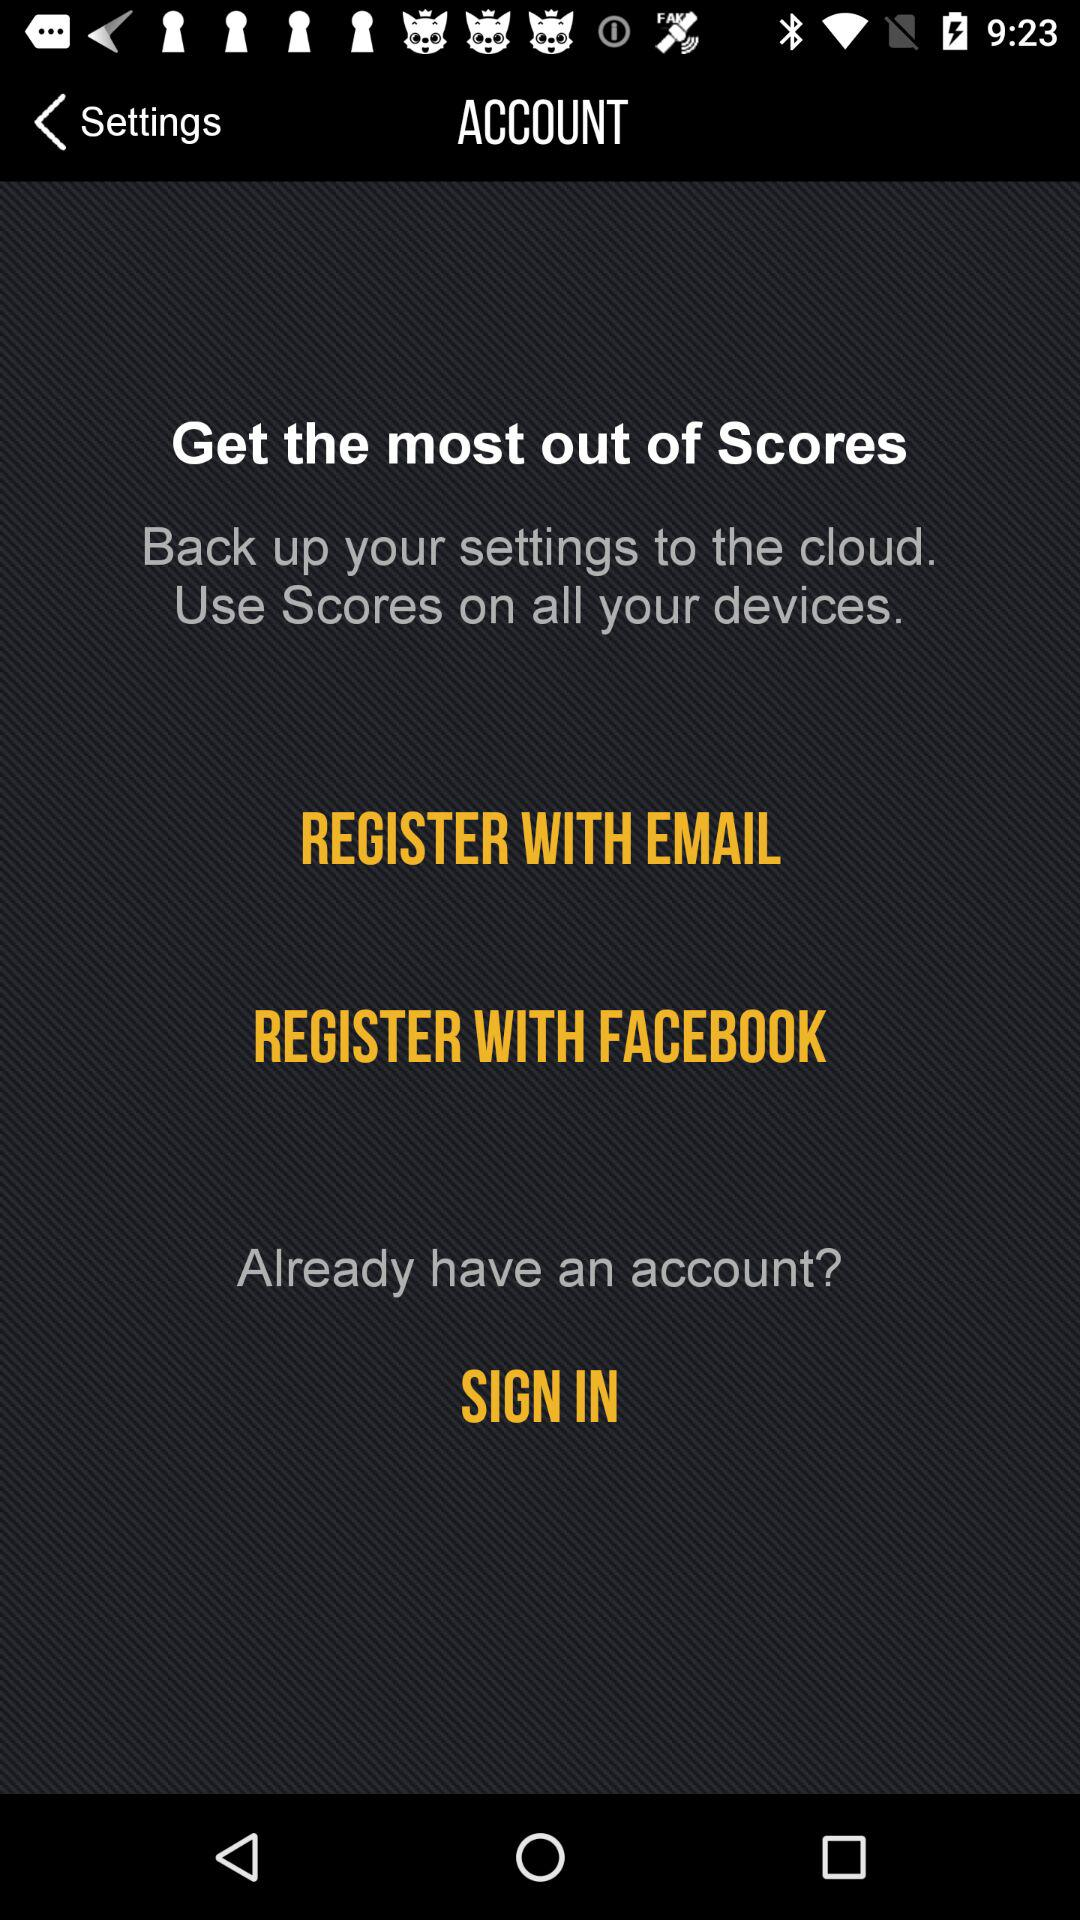Through which application can we register? You can register through "EMAIL" and "FACEBOOK". 